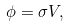<formula> <loc_0><loc_0><loc_500><loc_500>\phi = \sigma V ,</formula> 